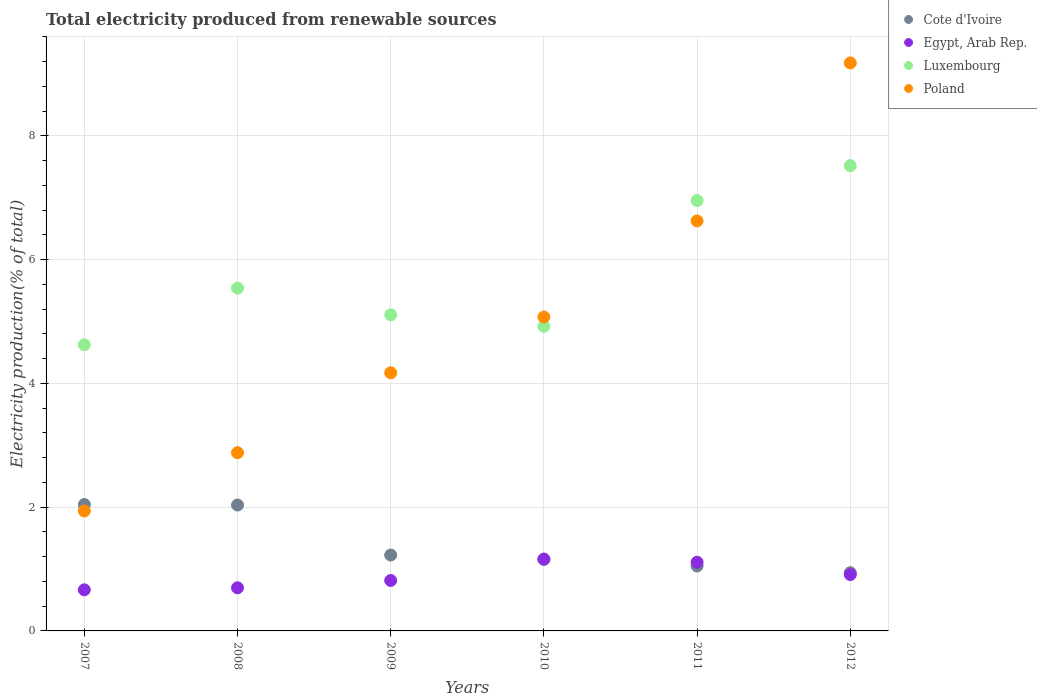What is the total electricity produced in Cote d'Ivoire in 2012?
Give a very brief answer. 0.94. Across all years, what is the maximum total electricity produced in Cote d'Ivoire?
Make the answer very short. 2.04. Across all years, what is the minimum total electricity produced in Poland?
Your answer should be very brief. 1.94. In which year was the total electricity produced in Poland maximum?
Offer a terse response. 2012. What is the total total electricity produced in Luxembourg in the graph?
Provide a short and direct response. 34.67. What is the difference between the total electricity produced in Luxembourg in 2007 and that in 2012?
Provide a short and direct response. -2.9. What is the difference between the total electricity produced in Poland in 2011 and the total electricity produced in Egypt, Arab Rep. in 2010?
Provide a succinct answer. 5.46. What is the average total electricity produced in Luxembourg per year?
Give a very brief answer. 5.78. In the year 2011, what is the difference between the total electricity produced in Luxembourg and total electricity produced in Cote d'Ivoire?
Your response must be concise. 5.9. In how many years, is the total electricity produced in Poland greater than 0.8 %?
Offer a terse response. 6. What is the ratio of the total electricity produced in Poland in 2007 to that in 2012?
Offer a terse response. 0.21. Is the difference between the total electricity produced in Luxembourg in 2007 and 2010 greater than the difference between the total electricity produced in Cote d'Ivoire in 2007 and 2010?
Make the answer very short. No. What is the difference between the highest and the second highest total electricity produced in Cote d'Ivoire?
Your response must be concise. 0.01. What is the difference between the highest and the lowest total electricity produced in Poland?
Provide a short and direct response. 7.24. Is the sum of the total electricity produced in Luxembourg in 2008 and 2009 greater than the maximum total electricity produced in Egypt, Arab Rep. across all years?
Ensure brevity in your answer.  Yes. Is it the case that in every year, the sum of the total electricity produced in Poland and total electricity produced in Luxembourg  is greater than the sum of total electricity produced in Cote d'Ivoire and total electricity produced in Egypt, Arab Rep.?
Offer a very short reply. Yes. Is the total electricity produced in Egypt, Arab Rep. strictly greater than the total electricity produced in Luxembourg over the years?
Give a very brief answer. No. Is the total electricity produced in Egypt, Arab Rep. strictly less than the total electricity produced in Luxembourg over the years?
Provide a succinct answer. Yes. How many dotlines are there?
Make the answer very short. 4. What is the difference between two consecutive major ticks on the Y-axis?
Your response must be concise. 2. Are the values on the major ticks of Y-axis written in scientific E-notation?
Make the answer very short. No. Does the graph contain grids?
Your response must be concise. Yes. Where does the legend appear in the graph?
Your answer should be compact. Top right. How are the legend labels stacked?
Your response must be concise. Vertical. What is the title of the graph?
Provide a succinct answer. Total electricity produced from renewable sources. Does "Korea (Democratic)" appear as one of the legend labels in the graph?
Keep it short and to the point. No. What is the label or title of the X-axis?
Provide a succinct answer. Years. What is the label or title of the Y-axis?
Provide a short and direct response. Electricity production(% of total). What is the Electricity production(% of total) in Cote d'Ivoire in 2007?
Offer a terse response. 2.04. What is the Electricity production(% of total) of Egypt, Arab Rep. in 2007?
Ensure brevity in your answer.  0.66. What is the Electricity production(% of total) of Luxembourg in 2007?
Your answer should be very brief. 4.62. What is the Electricity production(% of total) of Poland in 2007?
Provide a succinct answer. 1.94. What is the Electricity production(% of total) in Cote d'Ivoire in 2008?
Make the answer very short. 2.03. What is the Electricity production(% of total) in Egypt, Arab Rep. in 2008?
Your answer should be very brief. 0.7. What is the Electricity production(% of total) of Luxembourg in 2008?
Give a very brief answer. 5.54. What is the Electricity production(% of total) of Poland in 2008?
Make the answer very short. 2.88. What is the Electricity production(% of total) in Cote d'Ivoire in 2009?
Keep it short and to the point. 1.23. What is the Electricity production(% of total) of Egypt, Arab Rep. in 2009?
Offer a terse response. 0.82. What is the Electricity production(% of total) of Luxembourg in 2009?
Your response must be concise. 5.11. What is the Electricity production(% of total) of Poland in 2009?
Your answer should be compact. 4.17. What is the Electricity production(% of total) of Cote d'Ivoire in 2010?
Your response must be concise. 1.16. What is the Electricity production(% of total) in Egypt, Arab Rep. in 2010?
Provide a short and direct response. 1.16. What is the Electricity production(% of total) of Luxembourg in 2010?
Keep it short and to the point. 4.92. What is the Electricity production(% of total) in Poland in 2010?
Provide a succinct answer. 5.07. What is the Electricity production(% of total) of Cote d'Ivoire in 2011?
Provide a succinct answer. 1.05. What is the Electricity production(% of total) of Egypt, Arab Rep. in 2011?
Your answer should be very brief. 1.11. What is the Electricity production(% of total) in Luxembourg in 2011?
Ensure brevity in your answer.  6.95. What is the Electricity production(% of total) of Poland in 2011?
Provide a succinct answer. 6.62. What is the Electricity production(% of total) in Cote d'Ivoire in 2012?
Keep it short and to the point. 0.94. What is the Electricity production(% of total) in Egypt, Arab Rep. in 2012?
Make the answer very short. 0.91. What is the Electricity production(% of total) of Luxembourg in 2012?
Provide a succinct answer. 7.52. What is the Electricity production(% of total) of Poland in 2012?
Provide a short and direct response. 9.18. Across all years, what is the maximum Electricity production(% of total) of Cote d'Ivoire?
Your answer should be very brief. 2.04. Across all years, what is the maximum Electricity production(% of total) of Egypt, Arab Rep.?
Provide a short and direct response. 1.16. Across all years, what is the maximum Electricity production(% of total) of Luxembourg?
Keep it short and to the point. 7.52. Across all years, what is the maximum Electricity production(% of total) of Poland?
Make the answer very short. 9.18. Across all years, what is the minimum Electricity production(% of total) in Cote d'Ivoire?
Offer a very short reply. 0.94. Across all years, what is the minimum Electricity production(% of total) of Egypt, Arab Rep.?
Offer a very short reply. 0.66. Across all years, what is the minimum Electricity production(% of total) in Luxembourg?
Your answer should be very brief. 4.62. Across all years, what is the minimum Electricity production(% of total) of Poland?
Offer a very short reply. 1.94. What is the total Electricity production(% of total) in Cote d'Ivoire in the graph?
Provide a short and direct response. 8.45. What is the total Electricity production(% of total) of Egypt, Arab Rep. in the graph?
Provide a short and direct response. 5.36. What is the total Electricity production(% of total) of Luxembourg in the graph?
Ensure brevity in your answer.  34.67. What is the total Electricity production(% of total) of Poland in the graph?
Provide a succinct answer. 29.86. What is the difference between the Electricity production(% of total) of Cote d'Ivoire in 2007 and that in 2008?
Ensure brevity in your answer.  0.01. What is the difference between the Electricity production(% of total) of Egypt, Arab Rep. in 2007 and that in 2008?
Give a very brief answer. -0.03. What is the difference between the Electricity production(% of total) of Luxembourg in 2007 and that in 2008?
Give a very brief answer. -0.92. What is the difference between the Electricity production(% of total) of Poland in 2007 and that in 2008?
Provide a succinct answer. -0.94. What is the difference between the Electricity production(% of total) of Cote d'Ivoire in 2007 and that in 2009?
Provide a short and direct response. 0.82. What is the difference between the Electricity production(% of total) of Egypt, Arab Rep. in 2007 and that in 2009?
Offer a very short reply. -0.15. What is the difference between the Electricity production(% of total) of Luxembourg in 2007 and that in 2009?
Provide a short and direct response. -0.48. What is the difference between the Electricity production(% of total) in Poland in 2007 and that in 2009?
Make the answer very short. -2.23. What is the difference between the Electricity production(% of total) in Cote d'Ivoire in 2007 and that in 2010?
Your answer should be very brief. 0.89. What is the difference between the Electricity production(% of total) in Egypt, Arab Rep. in 2007 and that in 2010?
Your answer should be very brief. -0.5. What is the difference between the Electricity production(% of total) in Luxembourg in 2007 and that in 2010?
Your response must be concise. -0.3. What is the difference between the Electricity production(% of total) in Poland in 2007 and that in 2010?
Your answer should be compact. -3.13. What is the difference between the Electricity production(% of total) of Egypt, Arab Rep. in 2007 and that in 2011?
Keep it short and to the point. -0.45. What is the difference between the Electricity production(% of total) in Luxembourg in 2007 and that in 2011?
Provide a short and direct response. -2.33. What is the difference between the Electricity production(% of total) in Poland in 2007 and that in 2011?
Offer a very short reply. -4.69. What is the difference between the Electricity production(% of total) of Cote d'Ivoire in 2007 and that in 2012?
Ensure brevity in your answer.  1.1. What is the difference between the Electricity production(% of total) in Egypt, Arab Rep. in 2007 and that in 2012?
Your answer should be compact. -0.25. What is the difference between the Electricity production(% of total) in Luxembourg in 2007 and that in 2012?
Offer a very short reply. -2.9. What is the difference between the Electricity production(% of total) of Poland in 2007 and that in 2012?
Offer a terse response. -7.24. What is the difference between the Electricity production(% of total) of Cote d'Ivoire in 2008 and that in 2009?
Provide a succinct answer. 0.81. What is the difference between the Electricity production(% of total) in Egypt, Arab Rep. in 2008 and that in 2009?
Make the answer very short. -0.12. What is the difference between the Electricity production(% of total) in Luxembourg in 2008 and that in 2009?
Offer a terse response. 0.43. What is the difference between the Electricity production(% of total) in Poland in 2008 and that in 2009?
Offer a very short reply. -1.29. What is the difference between the Electricity production(% of total) of Cote d'Ivoire in 2008 and that in 2010?
Your answer should be compact. 0.88. What is the difference between the Electricity production(% of total) in Egypt, Arab Rep. in 2008 and that in 2010?
Your answer should be compact. -0.46. What is the difference between the Electricity production(% of total) in Luxembourg in 2008 and that in 2010?
Your response must be concise. 0.62. What is the difference between the Electricity production(% of total) in Poland in 2008 and that in 2010?
Ensure brevity in your answer.  -2.19. What is the difference between the Electricity production(% of total) of Cote d'Ivoire in 2008 and that in 2011?
Your response must be concise. 0.99. What is the difference between the Electricity production(% of total) of Egypt, Arab Rep. in 2008 and that in 2011?
Make the answer very short. -0.41. What is the difference between the Electricity production(% of total) in Luxembourg in 2008 and that in 2011?
Make the answer very short. -1.41. What is the difference between the Electricity production(% of total) in Poland in 2008 and that in 2011?
Make the answer very short. -3.75. What is the difference between the Electricity production(% of total) of Cote d'Ivoire in 2008 and that in 2012?
Your answer should be compact. 1.09. What is the difference between the Electricity production(% of total) of Egypt, Arab Rep. in 2008 and that in 2012?
Your response must be concise. -0.21. What is the difference between the Electricity production(% of total) of Luxembourg in 2008 and that in 2012?
Give a very brief answer. -1.98. What is the difference between the Electricity production(% of total) in Poland in 2008 and that in 2012?
Your answer should be very brief. -6.3. What is the difference between the Electricity production(% of total) in Cote d'Ivoire in 2009 and that in 2010?
Provide a succinct answer. 0.07. What is the difference between the Electricity production(% of total) in Egypt, Arab Rep. in 2009 and that in 2010?
Give a very brief answer. -0.35. What is the difference between the Electricity production(% of total) in Luxembourg in 2009 and that in 2010?
Offer a very short reply. 0.19. What is the difference between the Electricity production(% of total) of Poland in 2009 and that in 2010?
Your answer should be compact. -0.9. What is the difference between the Electricity production(% of total) of Cote d'Ivoire in 2009 and that in 2011?
Give a very brief answer. 0.18. What is the difference between the Electricity production(% of total) of Egypt, Arab Rep. in 2009 and that in 2011?
Your response must be concise. -0.29. What is the difference between the Electricity production(% of total) of Luxembourg in 2009 and that in 2011?
Your answer should be compact. -1.85. What is the difference between the Electricity production(% of total) of Poland in 2009 and that in 2011?
Provide a succinct answer. -2.45. What is the difference between the Electricity production(% of total) of Cote d'Ivoire in 2009 and that in 2012?
Give a very brief answer. 0.29. What is the difference between the Electricity production(% of total) of Egypt, Arab Rep. in 2009 and that in 2012?
Offer a terse response. -0.1. What is the difference between the Electricity production(% of total) in Luxembourg in 2009 and that in 2012?
Keep it short and to the point. -2.41. What is the difference between the Electricity production(% of total) in Poland in 2009 and that in 2012?
Make the answer very short. -5.01. What is the difference between the Electricity production(% of total) in Cote d'Ivoire in 2010 and that in 2011?
Your answer should be compact. 0.11. What is the difference between the Electricity production(% of total) of Egypt, Arab Rep. in 2010 and that in 2011?
Give a very brief answer. 0.05. What is the difference between the Electricity production(% of total) of Luxembourg in 2010 and that in 2011?
Provide a succinct answer. -2.03. What is the difference between the Electricity production(% of total) in Poland in 2010 and that in 2011?
Your answer should be very brief. -1.55. What is the difference between the Electricity production(% of total) of Cote d'Ivoire in 2010 and that in 2012?
Offer a terse response. 0.22. What is the difference between the Electricity production(% of total) in Luxembourg in 2010 and that in 2012?
Offer a terse response. -2.6. What is the difference between the Electricity production(% of total) in Poland in 2010 and that in 2012?
Ensure brevity in your answer.  -4.11. What is the difference between the Electricity production(% of total) of Cote d'Ivoire in 2011 and that in 2012?
Your answer should be compact. 0.11. What is the difference between the Electricity production(% of total) in Egypt, Arab Rep. in 2011 and that in 2012?
Ensure brevity in your answer.  0.2. What is the difference between the Electricity production(% of total) of Luxembourg in 2011 and that in 2012?
Offer a very short reply. -0.57. What is the difference between the Electricity production(% of total) in Poland in 2011 and that in 2012?
Make the answer very short. -2.55. What is the difference between the Electricity production(% of total) of Cote d'Ivoire in 2007 and the Electricity production(% of total) of Egypt, Arab Rep. in 2008?
Provide a short and direct response. 1.35. What is the difference between the Electricity production(% of total) of Cote d'Ivoire in 2007 and the Electricity production(% of total) of Luxembourg in 2008?
Provide a short and direct response. -3.5. What is the difference between the Electricity production(% of total) in Cote d'Ivoire in 2007 and the Electricity production(% of total) in Poland in 2008?
Offer a terse response. -0.84. What is the difference between the Electricity production(% of total) in Egypt, Arab Rep. in 2007 and the Electricity production(% of total) in Luxembourg in 2008?
Keep it short and to the point. -4.88. What is the difference between the Electricity production(% of total) in Egypt, Arab Rep. in 2007 and the Electricity production(% of total) in Poland in 2008?
Your answer should be very brief. -2.22. What is the difference between the Electricity production(% of total) of Luxembourg in 2007 and the Electricity production(% of total) of Poland in 2008?
Ensure brevity in your answer.  1.74. What is the difference between the Electricity production(% of total) in Cote d'Ivoire in 2007 and the Electricity production(% of total) in Egypt, Arab Rep. in 2009?
Ensure brevity in your answer.  1.23. What is the difference between the Electricity production(% of total) of Cote d'Ivoire in 2007 and the Electricity production(% of total) of Luxembourg in 2009?
Ensure brevity in your answer.  -3.07. What is the difference between the Electricity production(% of total) in Cote d'Ivoire in 2007 and the Electricity production(% of total) in Poland in 2009?
Keep it short and to the point. -2.13. What is the difference between the Electricity production(% of total) of Egypt, Arab Rep. in 2007 and the Electricity production(% of total) of Luxembourg in 2009?
Offer a very short reply. -4.44. What is the difference between the Electricity production(% of total) of Egypt, Arab Rep. in 2007 and the Electricity production(% of total) of Poland in 2009?
Your answer should be very brief. -3.51. What is the difference between the Electricity production(% of total) of Luxembourg in 2007 and the Electricity production(% of total) of Poland in 2009?
Offer a very short reply. 0.45. What is the difference between the Electricity production(% of total) of Cote d'Ivoire in 2007 and the Electricity production(% of total) of Egypt, Arab Rep. in 2010?
Provide a succinct answer. 0.88. What is the difference between the Electricity production(% of total) of Cote d'Ivoire in 2007 and the Electricity production(% of total) of Luxembourg in 2010?
Offer a very short reply. -2.88. What is the difference between the Electricity production(% of total) of Cote d'Ivoire in 2007 and the Electricity production(% of total) of Poland in 2010?
Provide a short and direct response. -3.03. What is the difference between the Electricity production(% of total) in Egypt, Arab Rep. in 2007 and the Electricity production(% of total) in Luxembourg in 2010?
Your response must be concise. -4.26. What is the difference between the Electricity production(% of total) in Egypt, Arab Rep. in 2007 and the Electricity production(% of total) in Poland in 2010?
Provide a succinct answer. -4.41. What is the difference between the Electricity production(% of total) in Luxembourg in 2007 and the Electricity production(% of total) in Poland in 2010?
Make the answer very short. -0.45. What is the difference between the Electricity production(% of total) of Cote d'Ivoire in 2007 and the Electricity production(% of total) of Egypt, Arab Rep. in 2011?
Offer a very short reply. 0.93. What is the difference between the Electricity production(% of total) in Cote d'Ivoire in 2007 and the Electricity production(% of total) in Luxembourg in 2011?
Your response must be concise. -4.91. What is the difference between the Electricity production(% of total) in Cote d'Ivoire in 2007 and the Electricity production(% of total) in Poland in 2011?
Provide a short and direct response. -4.58. What is the difference between the Electricity production(% of total) of Egypt, Arab Rep. in 2007 and the Electricity production(% of total) of Luxembourg in 2011?
Offer a terse response. -6.29. What is the difference between the Electricity production(% of total) in Egypt, Arab Rep. in 2007 and the Electricity production(% of total) in Poland in 2011?
Make the answer very short. -5.96. What is the difference between the Electricity production(% of total) of Luxembourg in 2007 and the Electricity production(% of total) of Poland in 2011?
Offer a very short reply. -2. What is the difference between the Electricity production(% of total) in Cote d'Ivoire in 2007 and the Electricity production(% of total) in Egypt, Arab Rep. in 2012?
Ensure brevity in your answer.  1.13. What is the difference between the Electricity production(% of total) of Cote d'Ivoire in 2007 and the Electricity production(% of total) of Luxembourg in 2012?
Offer a very short reply. -5.48. What is the difference between the Electricity production(% of total) in Cote d'Ivoire in 2007 and the Electricity production(% of total) in Poland in 2012?
Offer a terse response. -7.14. What is the difference between the Electricity production(% of total) of Egypt, Arab Rep. in 2007 and the Electricity production(% of total) of Luxembourg in 2012?
Make the answer very short. -6.86. What is the difference between the Electricity production(% of total) of Egypt, Arab Rep. in 2007 and the Electricity production(% of total) of Poland in 2012?
Provide a short and direct response. -8.51. What is the difference between the Electricity production(% of total) in Luxembourg in 2007 and the Electricity production(% of total) in Poland in 2012?
Offer a terse response. -4.55. What is the difference between the Electricity production(% of total) of Cote d'Ivoire in 2008 and the Electricity production(% of total) of Egypt, Arab Rep. in 2009?
Offer a terse response. 1.22. What is the difference between the Electricity production(% of total) in Cote d'Ivoire in 2008 and the Electricity production(% of total) in Luxembourg in 2009?
Ensure brevity in your answer.  -3.07. What is the difference between the Electricity production(% of total) in Cote d'Ivoire in 2008 and the Electricity production(% of total) in Poland in 2009?
Give a very brief answer. -2.14. What is the difference between the Electricity production(% of total) of Egypt, Arab Rep. in 2008 and the Electricity production(% of total) of Luxembourg in 2009?
Ensure brevity in your answer.  -4.41. What is the difference between the Electricity production(% of total) in Egypt, Arab Rep. in 2008 and the Electricity production(% of total) in Poland in 2009?
Your answer should be compact. -3.47. What is the difference between the Electricity production(% of total) of Luxembourg in 2008 and the Electricity production(% of total) of Poland in 2009?
Make the answer very short. 1.37. What is the difference between the Electricity production(% of total) in Cote d'Ivoire in 2008 and the Electricity production(% of total) in Egypt, Arab Rep. in 2010?
Give a very brief answer. 0.87. What is the difference between the Electricity production(% of total) in Cote d'Ivoire in 2008 and the Electricity production(% of total) in Luxembourg in 2010?
Your answer should be compact. -2.89. What is the difference between the Electricity production(% of total) in Cote d'Ivoire in 2008 and the Electricity production(% of total) in Poland in 2010?
Your answer should be compact. -3.04. What is the difference between the Electricity production(% of total) of Egypt, Arab Rep. in 2008 and the Electricity production(% of total) of Luxembourg in 2010?
Give a very brief answer. -4.23. What is the difference between the Electricity production(% of total) of Egypt, Arab Rep. in 2008 and the Electricity production(% of total) of Poland in 2010?
Keep it short and to the point. -4.38. What is the difference between the Electricity production(% of total) of Luxembourg in 2008 and the Electricity production(% of total) of Poland in 2010?
Give a very brief answer. 0.47. What is the difference between the Electricity production(% of total) in Cote d'Ivoire in 2008 and the Electricity production(% of total) in Egypt, Arab Rep. in 2011?
Your answer should be compact. 0.92. What is the difference between the Electricity production(% of total) of Cote d'Ivoire in 2008 and the Electricity production(% of total) of Luxembourg in 2011?
Provide a short and direct response. -4.92. What is the difference between the Electricity production(% of total) of Cote d'Ivoire in 2008 and the Electricity production(% of total) of Poland in 2011?
Your answer should be compact. -4.59. What is the difference between the Electricity production(% of total) in Egypt, Arab Rep. in 2008 and the Electricity production(% of total) in Luxembourg in 2011?
Give a very brief answer. -6.26. What is the difference between the Electricity production(% of total) in Egypt, Arab Rep. in 2008 and the Electricity production(% of total) in Poland in 2011?
Offer a terse response. -5.93. What is the difference between the Electricity production(% of total) in Luxembourg in 2008 and the Electricity production(% of total) in Poland in 2011?
Your answer should be compact. -1.09. What is the difference between the Electricity production(% of total) of Cote d'Ivoire in 2008 and the Electricity production(% of total) of Egypt, Arab Rep. in 2012?
Keep it short and to the point. 1.12. What is the difference between the Electricity production(% of total) of Cote d'Ivoire in 2008 and the Electricity production(% of total) of Luxembourg in 2012?
Give a very brief answer. -5.48. What is the difference between the Electricity production(% of total) of Cote d'Ivoire in 2008 and the Electricity production(% of total) of Poland in 2012?
Provide a succinct answer. -7.14. What is the difference between the Electricity production(% of total) in Egypt, Arab Rep. in 2008 and the Electricity production(% of total) in Luxembourg in 2012?
Ensure brevity in your answer.  -6.82. What is the difference between the Electricity production(% of total) of Egypt, Arab Rep. in 2008 and the Electricity production(% of total) of Poland in 2012?
Provide a short and direct response. -8.48. What is the difference between the Electricity production(% of total) in Luxembourg in 2008 and the Electricity production(% of total) in Poland in 2012?
Your response must be concise. -3.64. What is the difference between the Electricity production(% of total) in Cote d'Ivoire in 2009 and the Electricity production(% of total) in Egypt, Arab Rep. in 2010?
Keep it short and to the point. 0.07. What is the difference between the Electricity production(% of total) of Cote d'Ivoire in 2009 and the Electricity production(% of total) of Luxembourg in 2010?
Make the answer very short. -3.7. What is the difference between the Electricity production(% of total) of Cote d'Ivoire in 2009 and the Electricity production(% of total) of Poland in 2010?
Provide a short and direct response. -3.85. What is the difference between the Electricity production(% of total) of Egypt, Arab Rep. in 2009 and the Electricity production(% of total) of Luxembourg in 2010?
Keep it short and to the point. -4.11. What is the difference between the Electricity production(% of total) in Egypt, Arab Rep. in 2009 and the Electricity production(% of total) in Poland in 2010?
Your response must be concise. -4.26. What is the difference between the Electricity production(% of total) in Luxembourg in 2009 and the Electricity production(% of total) in Poland in 2010?
Keep it short and to the point. 0.04. What is the difference between the Electricity production(% of total) in Cote d'Ivoire in 2009 and the Electricity production(% of total) in Egypt, Arab Rep. in 2011?
Give a very brief answer. 0.12. What is the difference between the Electricity production(% of total) in Cote d'Ivoire in 2009 and the Electricity production(% of total) in Luxembourg in 2011?
Ensure brevity in your answer.  -5.73. What is the difference between the Electricity production(% of total) in Cote d'Ivoire in 2009 and the Electricity production(% of total) in Poland in 2011?
Offer a terse response. -5.4. What is the difference between the Electricity production(% of total) of Egypt, Arab Rep. in 2009 and the Electricity production(% of total) of Luxembourg in 2011?
Your answer should be very brief. -6.14. What is the difference between the Electricity production(% of total) of Egypt, Arab Rep. in 2009 and the Electricity production(% of total) of Poland in 2011?
Ensure brevity in your answer.  -5.81. What is the difference between the Electricity production(% of total) in Luxembourg in 2009 and the Electricity production(% of total) in Poland in 2011?
Provide a succinct answer. -1.52. What is the difference between the Electricity production(% of total) of Cote d'Ivoire in 2009 and the Electricity production(% of total) of Egypt, Arab Rep. in 2012?
Make the answer very short. 0.32. What is the difference between the Electricity production(% of total) in Cote d'Ivoire in 2009 and the Electricity production(% of total) in Luxembourg in 2012?
Your response must be concise. -6.29. What is the difference between the Electricity production(% of total) of Cote d'Ivoire in 2009 and the Electricity production(% of total) of Poland in 2012?
Ensure brevity in your answer.  -7.95. What is the difference between the Electricity production(% of total) of Egypt, Arab Rep. in 2009 and the Electricity production(% of total) of Luxembourg in 2012?
Offer a terse response. -6.7. What is the difference between the Electricity production(% of total) of Egypt, Arab Rep. in 2009 and the Electricity production(% of total) of Poland in 2012?
Provide a short and direct response. -8.36. What is the difference between the Electricity production(% of total) of Luxembourg in 2009 and the Electricity production(% of total) of Poland in 2012?
Give a very brief answer. -4.07. What is the difference between the Electricity production(% of total) of Cote d'Ivoire in 2010 and the Electricity production(% of total) of Egypt, Arab Rep. in 2011?
Offer a terse response. 0.05. What is the difference between the Electricity production(% of total) of Cote d'Ivoire in 2010 and the Electricity production(% of total) of Luxembourg in 2011?
Offer a very short reply. -5.8. What is the difference between the Electricity production(% of total) of Cote d'Ivoire in 2010 and the Electricity production(% of total) of Poland in 2011?
Offer a terse response. -5.47. What is the difference between the Electricity production(% of total) in Egypt, Arab Rep. in 2010 and the Electricity production(% of total) in Luxembourg in 2011?
Keep it short and to the point. -5.79. What is the difference between the Electricity production(% of total) in Egypt, Arab Rep. in 2010 and the Electricity production(% of total) in Poland in 2011?
Provide a short and direct response. -5.46. What is the difference between the Electricity production(% of total) of Luxembourg in 2010 and the Electricity production(% of total) of Poland in 2011?
Your answer should be compact. -1.7. What is the difference between the Electricity production(% of total) of Cote d'Ivoire in 2010 and the Electricity production(% of total) of Egypt, Arab Rep. in 2012?
Offer a very short reply. 0.25. What is the difference between the Electricity production(% of total) of Cote d'Ivoire in 2010 and the Electricity production(% of total) of Luxembourg in 2012?
Your answer should be very brief. -6.36. What is the difference between the Electricity production(% of total) in Cote d'Ivoire in 2010 and the Electricity production(% of total) in Poland in 2012?
Your answer should be compact. -8.02. What is the difference between the Electricity production(% of total) of Egypt, Arab Rep. in 2010 and the Electricity production(% of total) of Luxembourg in 2012?
Keep it short and to the point. -6.36. What is the difference between the Electricity production(% of total) in Egypt, Arab Rep. in 2010 and the Electricity production(% of total) in Poland in 2012?
Provide a succinct answer. -8.02. What is the difference between the Electricity production(% of total) of Luxembourg in 2010 and the Electricity production(% of total) of Poland in 2012?
Provide a short and direct response. -4.26. What is the difference between the Electricity production(% of total) in Cote d'Ivoire in 2011 and the Electricity production(% of total) in Egypt, Arab Rep. in 2012?
Your answer should be very brief. 0.14. What is the difference between the Electricity production(% of total) in Cote d'Ivoire in 2011 and the Electricity production(% of total) in Luxembourg in 2012?
Keep it short and to the point. -6.47. What is the difference between the Electricity production(% of total) of Cote d'Ivoire in 2011 and the Electricity production(% of total) of Poland in 2012?
Give a very brief answer. -8.13. What is the difference between the Electricity production(% of total) in Egypt, Arab Rep. in 2011 and the Electricity production(% of total) in Luxembourg in 2012?
Keep it short and to the point. -6.41. What is the difference between the Electricity production(% of total) in Egypt, Arab Rep. in 2011 and the Electricity production(% of total) in Poland in 2012?
Keep it short and to the point. -8.07. What is the difference between the Electricity production(% of total) of Luxembourg in 2011 and the Electricity production(% of total) of Poland in 2012?
Keep it short and to the point. -2.22. What is the average Electricity production(% of total) in Cote d'Ivoire per year?
Make the answer very short. 1.41. What is the average Electricity production(% of total) of Egypt, Arab Rep. per year?
Ensure brevity in your answer.  0.89. What is the average Electricity production(% of total) of Luxembourg per year?
Offer a very short reply. 5.78. What is the average Electricity production(% of total) of Poland per year?
Provide a short and direct response. 4.98. In the year 2007, what is the difference between the Electricity production(% of total) in Cote d'Ivoire and Electricity production(% of total) in Egypt, Arab Rep.?
Your response must be concise. 1.38. In the year 2007, what is the difference between the Electricity production(% of total) of Cote d'Ivoire and Electricity production(% of total) of Luxembourg?
Offer a very short reply. -2.58. In the year 2007, what is the difference between the Electricity production(% of total) in Cote d'Ivoire and Electricity production(% of total) in Poland?
Keep it short and to the point. 0.1. In the year 2007, what is the difference between the Electricity production(% of total) in Egypt, Arab Rep. and Electricity production(% of total) in Luxembourg?
Offer a terse response. -3.96. In the year 2007, what is the difference between the Electricity production(% of total) of Egypt, Arab Rep. and Electricity production(% of total) of Poland?
Your response must be concise. -1.27. In the year 2007, what is the difference between the Electricity production(% of total) in Luxembourg and Electricity production(% of total) in Poland?
Your response must be concise. 2.68. In the year 2008, what is the difference between the Electricity production(% of total) of Cote d'Ivoire and Electricity production(% of total) of Egypt, Arab Rep.?
Keep it short and to the point. 1.34. In the year 2008, what is the difference between the Electricity production(% of total) in Cote d'Ivoire and Electricity production(% of total) in Luxembourg?
Make the answer very short. -3.5. In the year 2008, what is the difference between the Electricity production(% of total) of Cote d'Ivoire and Electricity production(% of total) of Poland?
Your answer should be compact. -0.85. In the year 2008, what is the difference between the Electricity production(% of total) in Egypt, Arab Rep. and Electricity production(% of total) in Luxembourg?
Keep it short and to the point. -4.84. In the year 2008, what is the difference between the Electricity production(% of total) in Egypt, Arab Rep. and Electricity production(% of total) in Poland?
Keep it short and to the point. -2.18. In the year 2008, what is the difference between the Electricity production(% of total) of Luxembourg and Electricity production(% of total) of Poland?
Your response must be concise. 2.66. In the year 2009, what is the difference between the Electricity production(% of total) of Cote d'Ivoire and Electricity production(% of total) of Egypt, Arab Rep.?
Offer a terse response. 0.41. In the year 2009, what is the difference between the Electricity production(% of total) of Cote d'Ivoire and Electricity production(% of total) of Luxembourg?
Offer a terse response. -3.88. In the year 2009, what is the difference between the Electricity production(% of total) of Cote d'Ivoire and Electricity production(% of total) of Poland?
Your answer should be compact. -2.94. In the year 2009, what is the difference between the Electricity production(% of total) of Egypt, Arab Rep. and Electricity production(% of total) of Luxembourg?
Provide a succinct answer. -4.29. In the year 2009, what is the difference between the Electricity production(% of total) in Egypt, Arab Rep. and Electricity production(% of total) in Poland?
Make the answer very short. -3.36. In the year 2009, what is the difference between the Electricity production(% of total) of Luxembourg and Electricity production(% of total) of Poland?
Ensure brevity in your answer.  0.94. In the year 2010, what is the difference between the Electricity production(% of total) of Cote d'Ivoire and Electricity production(% of total) of Egypt, Arab Rep.?
Provide a succinct answer. -0. In the year 2010, what is the difference between the Electricity production(% of total) of Cote d'Ivoire and Electricity production(% of total) of Luxembourg?
Your response must be concise. -3.77. In the year 2010, what is the difference between the Electricity production(% of total) of Cote d'Ivoire and Electricity production(% of total) of Poland?
Your response must be concise. -3.92. In the year 2010, what is the difference between the Electricity production(% of total) of Egypt, Arab Rep. and Electricity production(% of total) of Luxembourg?
Provide a succinct answer. -3.76. In the year 2010, what is the difference between the Electricity production(% of total) in Egypt, Arab Rep. and Electricity production(% of total) in Poland?
Offer a terse response. -3.91. In the year 2010, what is the difference between the Electricity production(% of total) of Luxembourg and Electricity production(% of total) of Poland?
Provide a short and direct response. -0.15. In the year 2011, what is the difference between the Electricity production(% of total) of Cote d'Ivoire and Electricity production(% of total) of Egypt, Arab Rep.?
Provide a short and direct response. -0.06. In the year 2011, what is the difference between the Electricity production(% of total) of Cote d'Ivoire and Electricity production(% of total) of Luxembourg?
Make the answer very short. -5.9. In the year 2011, what is the difference between the Electricity production(% of total) of Cote d'Ivoire and Electricity production(% of total) of Poland?
Provide a short and direct response. -5.58. In the year 2011, what is the difference between the Electricity production(% of total) of Egypt, Arab Rep. and Electricity production(% of total) of Luxembourg?
Give a very brief answer. -5.84. In the year 2011, what is the difference between the Electricity production(% of total) in Egypt, Arab Rep. and Electricity production(% of total) in Poland?
Offer a very short reply. -5.51. In the year 2011, what is the difference between the Electricity production(% of total) of Luxembourg and Electricity production(% of total) of Poland?
Provide a succinct answer. 0.33. In the year 2012, what is the difference between the Electricity production(% of total) in Cote d'Ivoire and Electricity production(% of total) in Egypt, Arab Rep.?
Ensure brevity in your answer.  0.03. In the year 2012, what is the difference between the Electricity production(% of total) in Cote d'Ivoire and Electricity production(% of total) in Luxembourg?
Your answer should be very brief. -6.58. In the year 2012, what is the difference between the Electricity production(% of total) of Cote d'Ivoire and Electricity production(% of total) of Poland?
Make the answer very short. -8.24. In the year 2012, what is the difference between the Electricity production(% of total) in Egypt, Arab Rep. and Electricity production(% of total) in Luxembourg?
Give a very brief answer. -6.61. In the year 2012, what is the difference between the Electricity production(% of total) of Egypt, Arab Rep. and Electricity production(% of total) of Poland?
Ensure brevity in your answer.  -8.27. In the year 2012, what is the difference between the Electricity production(% of total) in Luxembourg and Electricity production(% of total) in Poland?
Give a very brief answer. -1.66. What is the ratio of the Electricity production(% of total) of Egypt, Arab Rep. in 2007 to that in 2008?
Give a very brief answer. 0.95. What is the ratio of the Electricity production(% of total) of Luxembourg in 2007 to that in 2008?
Your answer should be very brief. 0.83. What is the ratio of the Electricity production(% of total) of Poland in 2007 to that in 2008?
Your answer should be very brief. 0.67. What is the ratio of the Electricity production(% of total) in Cote d'Ivoire in 2007 to that in 2009?
Provide a short and direct response. 1.67. What is the ratio of the Electricity production(% of total) of Egypt, Arab Rep. in 2007 to that in 2009?
Give a very brief answer. 0.81. What is the ratio of the Electricity production(% of total) in Luxembourg in 2007 to that in 2009?
Make the answer very short. 0.91. What is the ratio of the Electricity production(% of total) in Poland in 2007 to that in 2009?
Offer a very short reply. 0.46. What is the ratio of the Electricity production(% of total) of Cote d'Ivoire in 2007 to that in 2010?
Provide a succinct answer. 1.77. What is the ratio of the Electricity production(% of total) in Egypt, Arab Rep. in 2007 to that in 2010?
Your answer should be compact. 0.57. What is the ratio of the Electricity production(% of total) in Luxembourg in 2007 to that in 2010?
Offer a very short reply. 0.94. What is the ratio of the Electricity production(% of total) of Poland in 2007 to that in 2010?
Provide a short and direct response. 0.38. What is the ratio of the Electricity production(% of total) in Cote d'Ivoire in 2007 to that in 2011?
Your answer should be compact. 1.95. What is the ratio of the Electricity production(% of total) in Egypt, Arab Rep. in 2007 to that in 2011?
Keep it short and to the point. 0.6. What is the ratio of the Electricity production(% of total) of Luxembourg in 2007 to that in 2011?
Provide a succinct answer. 0.66. What is the ratio of the Electricity production(% of total) of Poland in 2007 to that in 2011?
Keep it short and to the point. 0.29. What is the ratio of the Electricity production(% of total) of Cote d'Ivoire in 2007 to that in 2012?
Provide a short and direct response. 2.17. What is the ratio of the Electricity production(% of total) of Egypt, Arab Rep. in 2007 to that in 2012?
Make the answer very short. 0.73. What is the ratio of the Electricity production(% of total) in Luxembourg in 2007 to that in 2012?
Keep it short and to the point. 0.61. What is the ratio of the Electricity production(% of total) of Poland in 2007 to that in 2012?
Keep it short and to the point. 0.21. What is the ratio of the Electricity production(% of total) of Cote d'Ivoire in 2008 to that in 2009?
Offer a very short reply. 1.66. What is the ratio of the Electricity production(% of total) of Egypt, Arab Rep. in 2008 to that in 2009?
Keep it short and to the point. 0.85. What is the ratio of the Electricity production(% of total) of Luxembourg in 2008 to that in 2009?
Keep it short and to the point. 1.08. What is the ratio of the Electricity production(% of total) in Poland in 2008 to that in 2009?
Your response must be concise. 0.69. What is the ratio of the Electricity production(% of total) of Cote d'Ivoire in 2008 to that in 2010?
Provide a succinct answer. 1.76. What is the ratio of the Electricity production(% of total) in Egypt, Arab Rep. in 2008 to that in 2010?
Make the answer very short. 0.6. What is the ratio of the Electricity production(% of total) of Luxembourg in 2008 to that in 2010?
Provide a succinct answer. 1.13. What is the ratio of the Electricity production(% of total) in Poland in 2008 to that in 2010?
Provide a succinct answer. 0.57. What is the ratio of the Electricity production(% of total) of Cote d'Ivoire in 2008 to that in 2011?
Your answer should be very brief. 1.94. What is the ratio of the Electricity production(% of total) of Egypt, Arab Rep. in 2008 to that in 2011?
Your answer should be very brief. 0.63. What is the ratio of the Electricity production(% of total) in Luxembourg in 2008 to that in 2011?
Provide a succinct answer. 0.8. What is the ratio of the Electricity production(% of total) in Poland in 2008 to that in 2011?
Give a very brief answer. 0.43. What is the ratio of the Electricity production(% of total) of Cote d'Ivoire in 2008 to that in 2012?
Provide a short and direct response. 2.16. What is the ratio of the Electricity production(% of total) of Egypt, Arab Rep. in 2008 to that in 2012?
Provide a short and direct response. 0.77. What is the ratio of the Electricity production(% of total) in Luxembourg in 2008 to that in 2012?
Your response must be concise. 0.74. What is the ratio of the Electricity production(% of total) of Poland in 2008 to that in 2012?
Your answer should be compact. 0.31. What is the ratio of the Electricity production(% of total) of Cote d'Ivoire in 2009 to that in 2010?
Provide a succinct answer. 1.06. What is the ratio of the Electricity production(% of total) in Egypt, Arab Rep. in 2009 to that in 2010?
Your answer should be compact. 0.7. What is the ratio of the Electricity production(% of total) in Luxembourg in 2009 to that in 2010?
Make the answer very short. 1.04. What is the ratio of the Electricity production(% of total) in Poland in 2009 to that in 2010?
Offer a terse response. 0.82. What is the ratio of the Electricity production(% of total) in Cote d'Ivoire in 2009 to that in 2011?
Keep it short and to the point. 1.17. What is the ratio of the Electricity production(% of total) in Egypt, Arab Rep. in 2009 to that in 2011?
Give a very brief answer. 0.73. What is the ratio of the Electricity production(% of total) of Luxembourg in 2009 to that in 2011?
Ensure brevity in your answer.  0.73. What is the ratio of the Electricity production(% of total) of Poland in 2009 to that in 2011?
Offer a very short reply. 0.63. What is the ratio of the Electricity production(% of total) of Cote d'Ivoire in 2009 to that in 2012?
Your answer should be compact. 1.3. What is the ratio of the Electricity production(% of total) of Egypt, Arab Rep. in 2009 to that in 2012?
Your response must be concise. 0.9. What is the ratio of the Electricity production(% of total) in Luxembourg in 2009 to that in 2012?
Make the answer very short. 0.68. What is the ratio of the Electricity production(% of total) in Poland in 2009 to that in 2012?
Your response must be concise. 0.45. What is the ratio of the Electricity production(% of total) in Cote d'Ivoire in 2010 to that in 2011?
Ensure brevity in your answer.  1.1. What is the ratio of the Electricity production(% of total) in Egypt, Arab Rep. in 2010 to that in 2011?
Your answer should be compact. 1.05. What is the ratio of the Electricity production(% of total) in Luxembourg in 2010 to that in 2011?
Make the answer very short. 0.71. What is the ratio of the Electricity production(% of total) of Poland in 2010 to that in 2011?
Provide a short and direct response. 0.77. What is the ratio of the Electricity production(% of total) in Cote d'Ivoire in 2010 to that in 2012?
Make the answer very short. 1.23. What is the ratio of the Electricity production(% of total) of Egypt, Arab Rep. in 2010 to that in 2012?
Your response must be concise. 1.27. What is the ratio of the Electricity production(% of total) in Luxembourg in 2010 to that in 2012?
Offer a very short reply. 0.65. What is the ratio of the Electricity production(% of total) of Poland in 2010 to that in 2012?
Offer a very short reply. 0.55. What is the ratio of the Electricity production(% of total) of Cote d'Ivoire in 2011 to that in 2012?
Provide a succinct answer. 1.12. What is the ratio of the Electricity production(% of total) in Egypt, Arab Rep. in 2011 to that in 2012?
Your response must be concise. 1.22. What is the ratio of the Electricity production(% of total) of Luxembourg in 2011 to that in 2012?
Keep it short and to the point. 0.92. What is the ratio of the Electricity production(% of total) of Poland in 2011 to that in 2012?
Your response must be concise. 0.72. What is the difference between the highest and the second highest Electricity production(% of total) in Cote d'Ivoire?
Your response must be concise. 0.01. What is the difference between the highest and the second highest Electricity production(% of total) in Egypt, Arab Rep.?
Your answer should be compact. 0.05. What is the difference between the highest and the second highest Electricity production(% of total) in Luxembourg?
Provide a short and direct response. 0.57. What is the difference between the highest and the second highest Electricity production(% of total) of Poland?
Offer a terse response. 2.55. What is the difference between the highest and the lowest Electricity production(% of total) of Cote d'Ivoire?
Your response must be concise. 1.1. What is the difference between the highest and the lowest Electricity production(% of total) in Egypt, Arab Rep.?
Provide a short and direct response. 0.5. What is the difference between the highest and the lowest Electricity production(% of total) of Luxembourg?
Provide a short and direct response. 2.9. What is the difference between the highest and the lowest Electricity production(% of total) of Poland?
Keep it short and to the point. 7.24. 